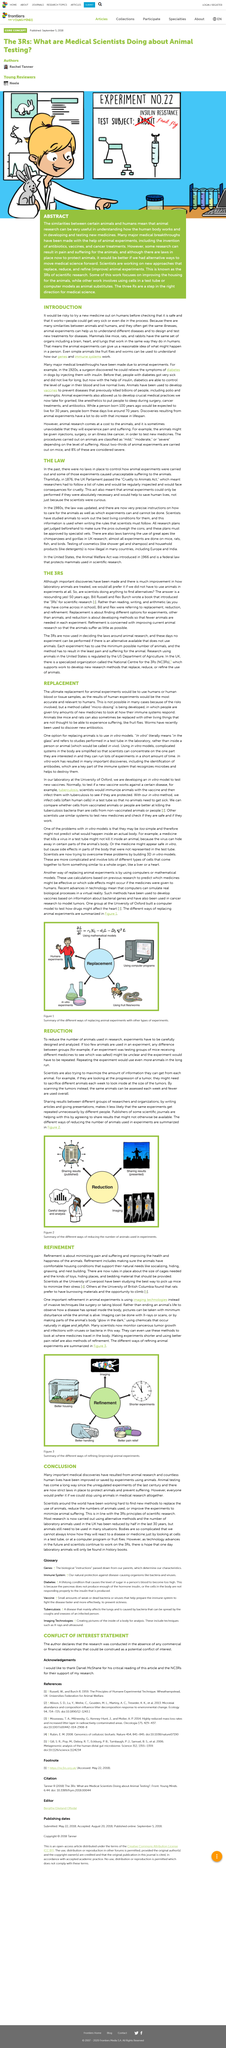Mention a couple of crucial points in this snapshot. This article is about the topic of replacement, which is the focus of the content presented. Advances in technology, such as the use of computers and virtual reality simulations, have greatly assisted in the testing process, particularly in the field of biology. The Cruelty to Animals Act and the Animal Welfare Act are two acts that have been passed to address animal experiments. The title of the article is "REPLACEMENT". The laboratory is located at the University of Oxford. 